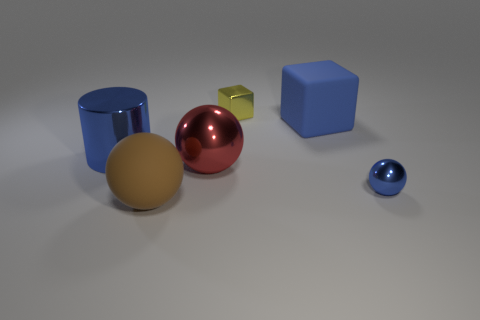Subtract all brown rubber balls. How many balls are left? 2 Subtract all yellow blocks. How many blocks are left? 1 Subtract all cubes. How many objects are left? 4 Add 2 tiny blue spheres. How many objects exist? 8 Subtract all blue balls. How many yellow blocks are left? 1 Subtract all metallic cylinders. Subtract all small blue metal spheres. How many objects are left? 4 Add 6 tiny yellow objects. How many tiny yellow objects are left? 7 Add 1 gray metallic objects. How many gray metallic objects exist? 1 Subtract 1 blue cubes. How many objects are left? 5 Subtract 1 cylinders. How many cylinders are left? 0 